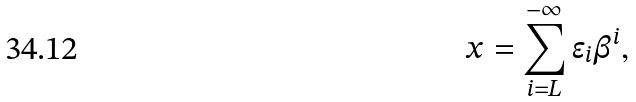Convert formula to latex. <formula><loc_0><loc_0><loc_500><loc_500>x = \sum _ { i = L } ^ { - \infty } \epsilon _ { i } \beta ^ { i } ,</formula> 